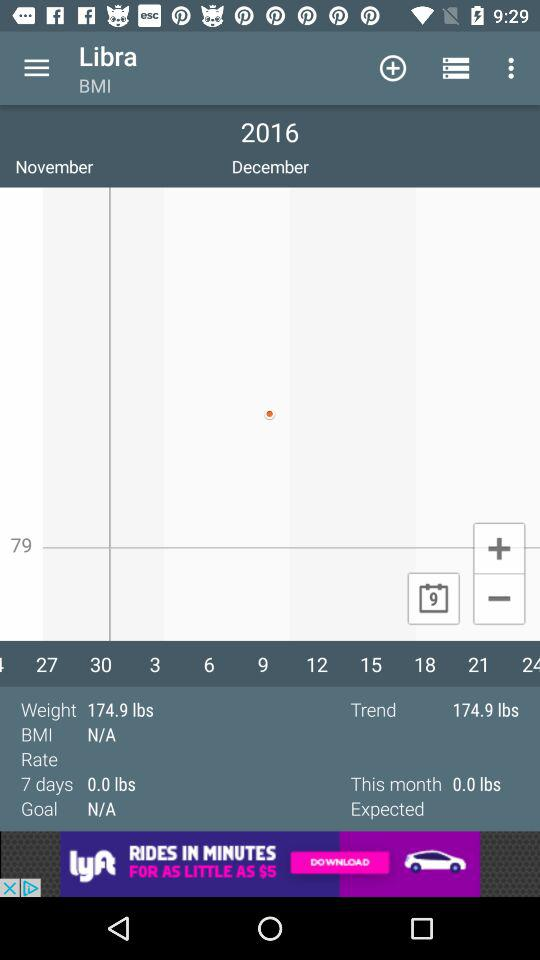What is the weight? The weight is 174.9 lbs. 